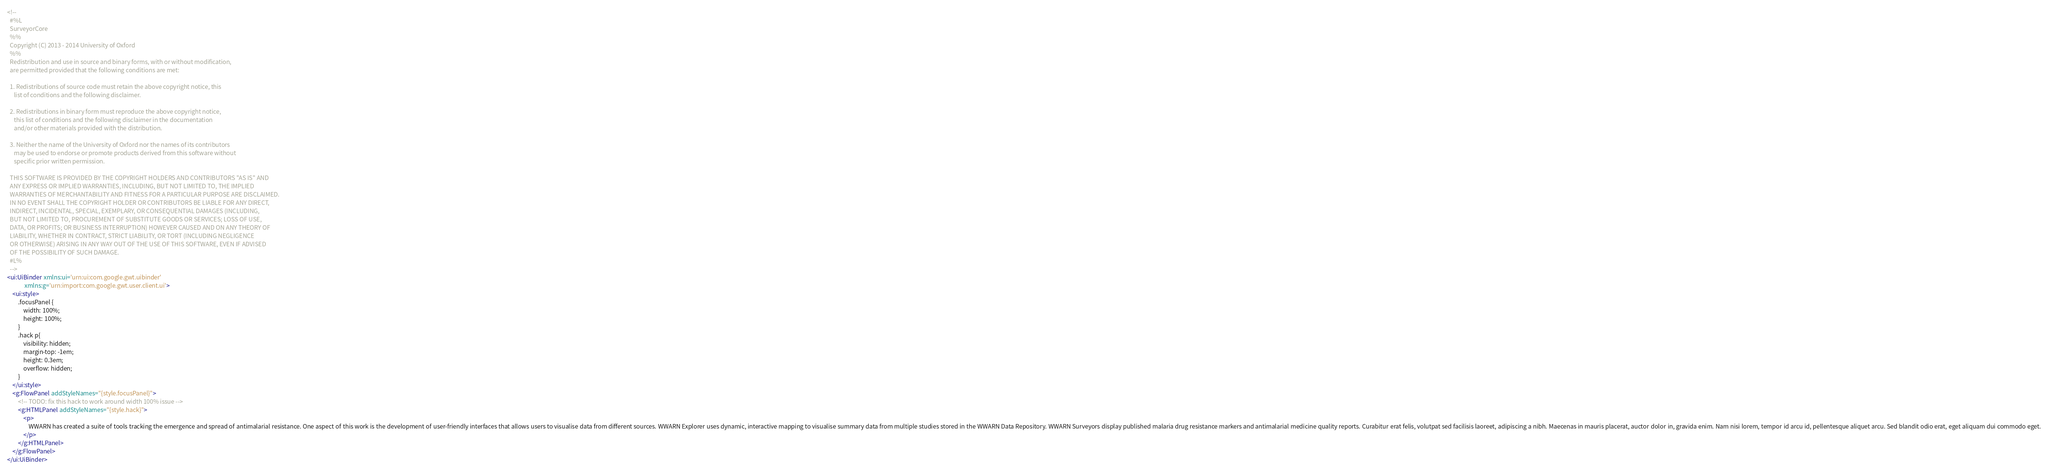Convert code to text. <code><loc_0><loc_0><loc_500><loc_500><_XML_><!--
  #%L
  SurveyorCore
  %%
  Copyright (C) 2013 - 2014 University of Oxford
  %%
  Redistribution and use in source and binary forms, with or without modification,
  are permitted provided that the following conditions are met:
  
  1. Redistributions of source code must retain the above copyright notice, this
     list of conditions and the following disclaimer.
  
  2. Redistributions in binary form must reproduce the above copyright notice,
     this list of conditions and the following disclaimer in the documentation
     and/or other materials provided with the distribution.
  
  3. Neither the name of the University of Oxford nor the names of its contributors
     may be used to endorse or promote products derived from this software without
     specific prior written permission.
  
  THIS SOFTWARE IS PROVIDED BY THE COPYRIGHT HOLDERS AND CONTRIBUTORS "AS IS" AND
  ANY EXPRESS OR IMPLIED WARRANTIES, INCLUDING, BUT NOT LIMITED TO, THE IMPLIED
  WARRANTIES OF MERCHANTABILITY AND FITNESS FOR A PARTICULAR PURPOSE ARE DISCLAIMED.
  IN NO EVENT SHALL THE COPYRIGHT HOLDER OR CONTRIBUTORS BE LIABLE FOR ANY DIRECT,
  INDIRECT, INCIDENTAL, SPECIAL, EXEMPLARY, OR CONSEQUENTIAL DAMAGES (INCLUDING,
  BUT NOT LIMITED TO, PROCUREMENT OF SUBSTITUTE GOODS OR SERVICES; LOSS OF USE,
  DATA, OR PROFITS; OR BUSINESS INTERRUPTION) HOWEVER CAUSED AND ON ANY THEORY OF
  LIABILITY, WHETHER IN CONTRACT, STRICT LIABILITY, OR TORT (INCLUDING NEGLIGENCE
  OR OTHERWISE) ARISING IN ANY WAY OUT OF THE USE OF THIS SOFTWARE, EVEN IF ADVISED
  OF THE POSSIBILITY OF SUCH DAMAGE.
  #L%
  -->
<ui:UiBinder xmlns:ui='urn:ui:com.google.gwt.uibinder'
             xmlns:g='urn:import:com.google.gwt.user.client.ui'>
    <ui:style>
        .focusPanel {
            width: 100%;
            height: 100%;
        }
        .hack p{
            visibility: hidden;
            margin-top: -1em;
            height: 0.3em;
            overflow: hidden;
        }
    </ui:style>
    <g:FlowPanel addStyleNames="{style.focusPanel}">
        <!-- TODO: fix this hack to work around width 100% issue -->
        <g:HTMLPanel addStyleNames="{style.hack}">
            <p>
                WWARN has created a suite of tools tracking the emergence and spread of antimalarial resistance. One aspect of this work is the development of user-friendly interfaces that allows users to visualise data from different sources. WWARN Explorer uses dynamic, interactive mapping to visualise summary data from multiple studies stored in the WWARN Data Repository. WWARN Surveyors display published malaria drug resistance markers and antimalarial medicine quality reports. Curabitur erat felis, volutpat sed facilisis laoreet, adipiscing a nibh. Maecenas in mauris placerat, auctor dolor in, gravida enim. Nam nisi lorem, tempor id arcu id, pellentesque aliquet arcu. Sed blandit odio erat, eget aliquam dui commodo eget.
            </p>
        </g:HTMLPanel>
    </g:FlowPanel>
</ui:UiBinder></code> 